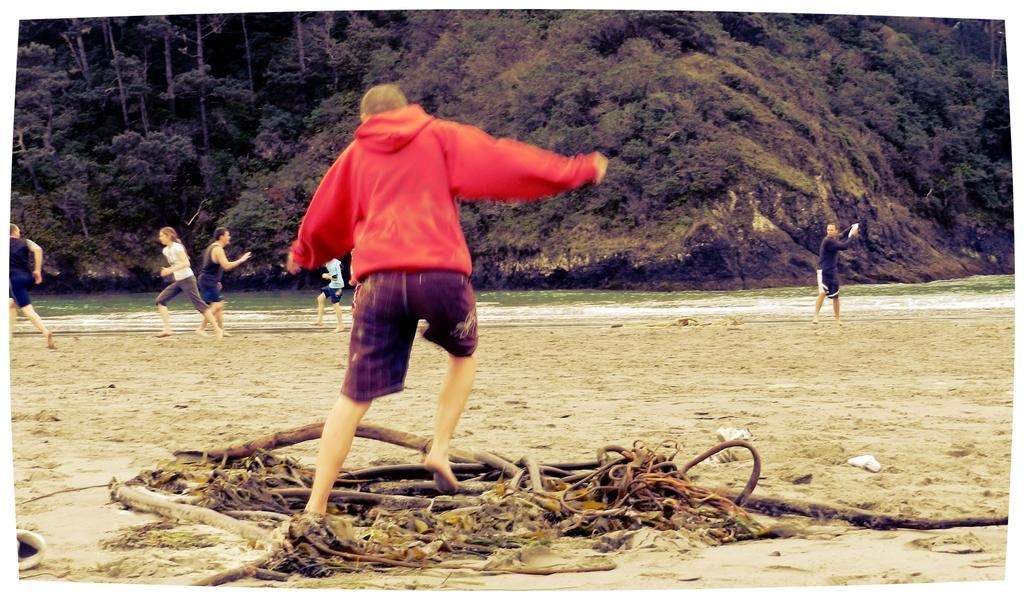What are the people in the image doing? The people in the image are standing and running. What can be seen in the background of the image? There is water, trees, and hills visible in the background of the image. What type of zephyr can be seen blowing through the frame in the image? There is no zephyr present in the image, and the image does not have a frame. 